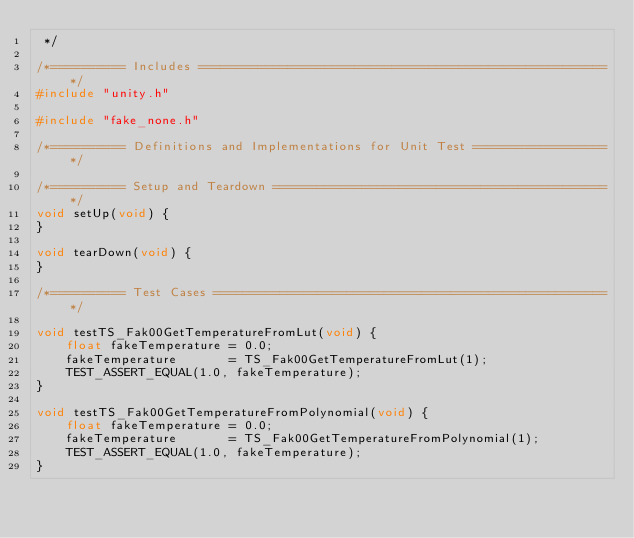Convert code to text. <code><loc_0><loc_0><loc_500><loc_500><_C_> */

/*========== Includes =======================================================*/
#include "unity.h"

#include "fake_none.h"

/*========== Definitions and Implementations for Unit Test ==================*/

/*========== Setup and Teardown =============================================*/
void setUp(void) {
}

void tearDown(void) {
}

/*========== Test Cases =====================================================*/

void testTS_Fak00GetTemperatureFromLut(void) {
    float fakeTemperature = 0.0;
    fakeTemperature       = TS_Fak00GetTemperatureFromLut(1);
    TEST_ASSERT_EQUAL(1.0, fakeTemperature);
}

void testTS_Fak00GetTemperatureFromPolynomial(void) {
    float fakeTemperature = 0.0;
    fakeTemperature       = TS_Fak00GetTemperatureFromPolynomial(1);
    TEST_ASSERT_EQUAL(1.0, fakeTemperature);
}
</code> 